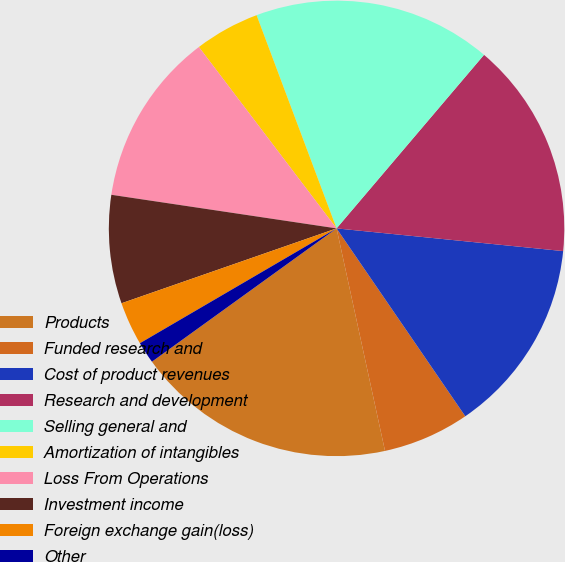Convert chart. <chart><loc_0><loc_0><loc_500><loc_500><pie_chart><fcel>Products<fcel>Funded research and<fcel>Cost of product revenues<fcel>Research and development<fcel>Selling general and<fcel>Amortization of intangibles<fcel>Loss From Operations<fcel>Investment income<fcel>Foreign exchange gain(loss)<fcel>Other<nl><fcel>18.46%<fcel>6.15%<fcel>13.85%<fcel>15.38%<fcel>16.92%<fcel>4.62%<fcel>12.31%<fcel>7.69%<fcel>3.08%<fcel>1.54%<nl></chart> 